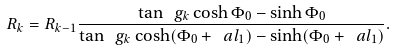Convert formula to latex. <formula><loc_0><loc_0><loc_500><loc_500>R _ { k } = R _ { k - 1 } \frac { \tan \ g _ { k } \cosh \Phi _ { 0 } - \sinh \Phi _ { 0 } } { \tan \ g _ { k } \cosh ( \Phi _ { 0 } + \ a l _ { 1 } ) - \sinh ( \Phi _ { 0 } + \ a l _ { 1 } ) } .</formula> 